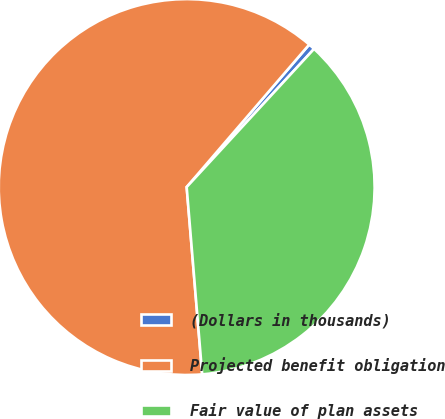Convert chart to OTSL. <chart><loc_0><loc_0><loc_500><loc_500><pie_chart><fcel>(Dollars in thousands)<fcel>Projected benefit obligation<fcel>Fair value of plan assets<nl><fcel>0.55%<fcel>62.62%<fcel>36.83%<nl></chart> 